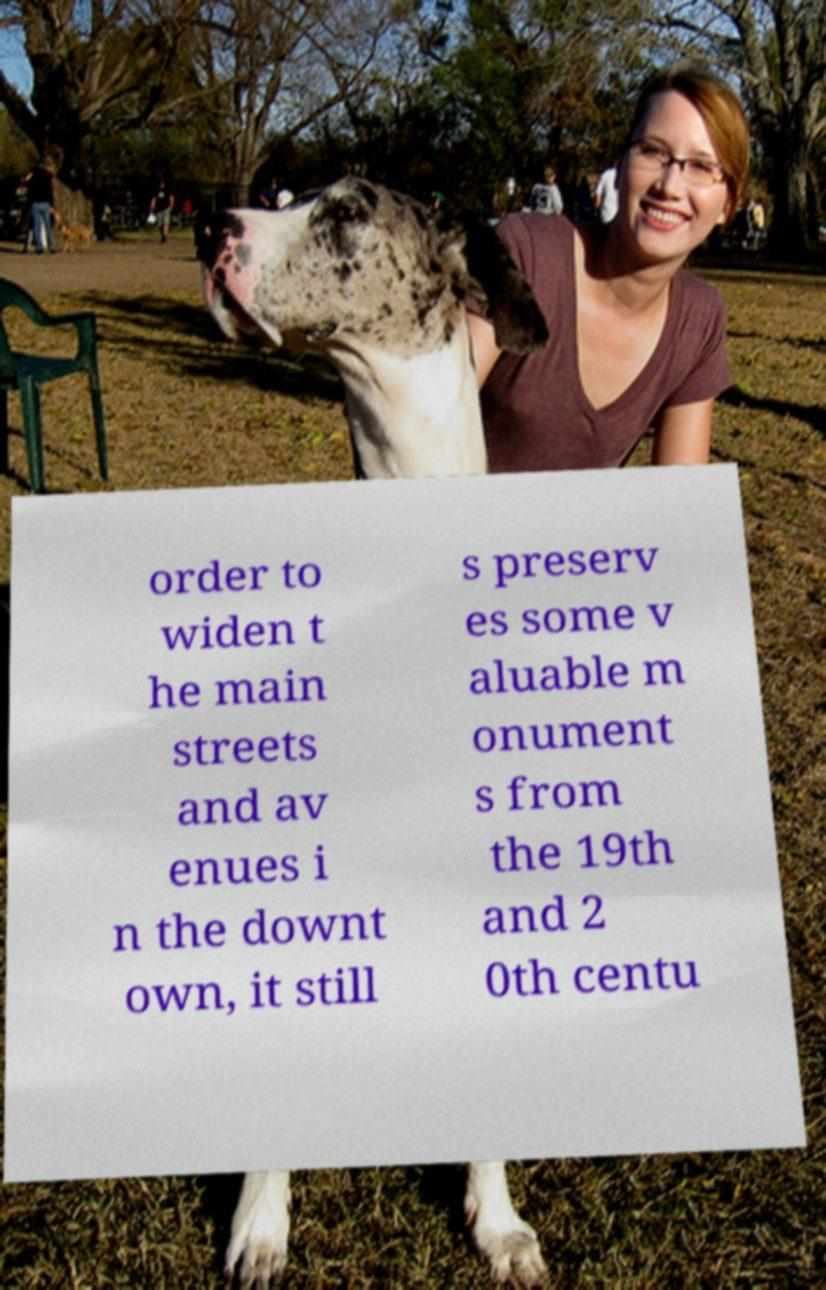For documentation purposes, I need the text within this image transcribed. Could you provide that? order to widen t he main streets and av enues i n the downt own, it still s preserv es some v aluable m onument s from the 19th and 2 0th centu 